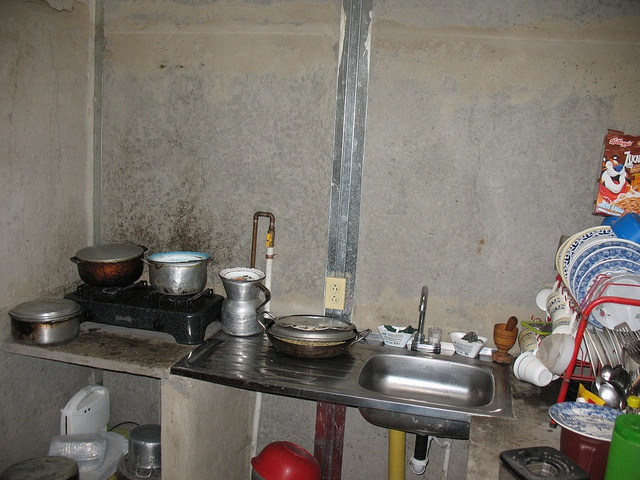Describe the objects in this image and their specific colors. I can see sink in black, gray, darkgray, and lightgray tones, bowl in black, gray, and darkgray tones, bowl in black, gray, darkgray, and lightgray tones, bowl in black, maroon, and brown tones, and bottle in black, darkgreen, and gray tones in this image. 